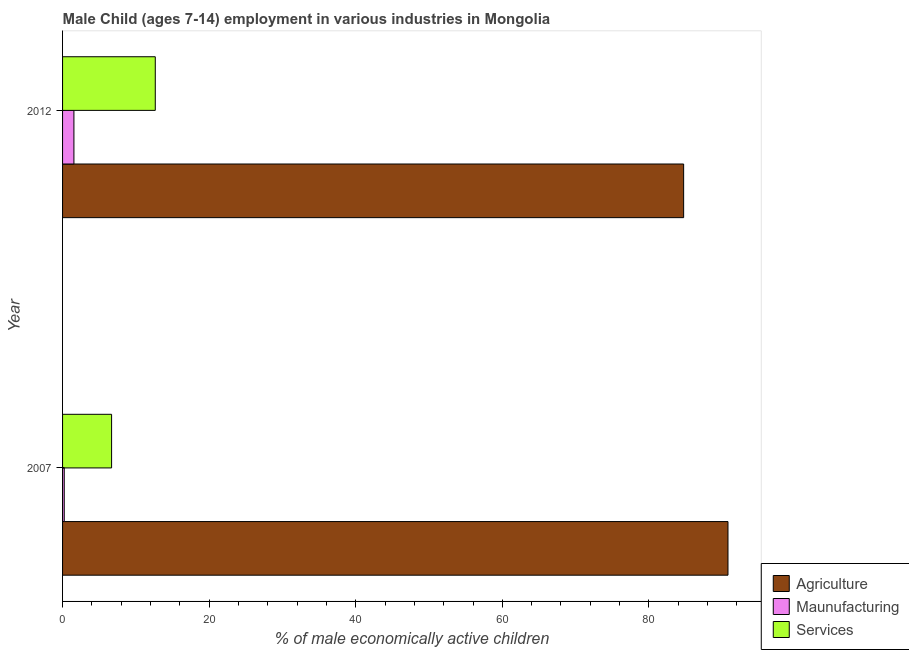How many different coloured bars are there?
Offer a very short reply. 3. How many groups of bars are there?
Your response must be concise. 2. Are the number of bars on each tick of the Y-axis equal?
Offer a very short reply. Yes. What is the percentage of economically active children in agriculture in 2007?
Provide a short and direct response. 90.79. Across all years, what is the maximum percentage of economically active children in manufacturing?
Make the answer very short. 1.55. Across all years, what is the minimum percentage of economically active children in services?
Your answer should be compact. 6.69. In which year was the percentage of economically active children in services minimum?
Provide a succinct answer. 2007. What is the total percentage of economically active children in manufacturing in the graph?
Make the answer very short. 1.78. What is the difference between the percentage of economically active children in services in 2007 and that in 2012?
Ensure brevity in your answer.  -5.96. What is the difference between the percentage of economically active children in services in 2007 and the percentage of economically active children in agriculture in 2012?
Your answer should be compact. -78.05. What is the average percentage of economically active children in manufacturing per year?
Your answer should be very brief. 0.89. In how many years, is the percentage of economically active children in manufacturing greater than 60 %?
Keep it short and to the point. 0. What is the ratio of the percentage of economically active children in services in 2007 to that in 2012?
Offer a terse response. 0.53. What does the 1st bar from the top in 2012 represents?
Your response must be concise. Services. What does the 2nd bar from the bottom in 2007 represents?
Ensure brevity in your answer.  Maunufacturing. Is it the case that in every year, the sum of the percentage of economically active children in agriculture and percentage of economically active children in manufacturing is greater than the percentage of economically active children in services?
Keep it short and to the point. Yes. Are all the bars in the graph horizontal?
Ensure brevity in your answer.  Yes. Are the values on the major ticks of X-axis written in scientific E-notation?
Provide a succinct answer. No. Does the graph contain any zero values?
Offer a terse response. No. How are the legend labels stacked?
Keep it short and to the point. Vertical. What is the title of the graph?
Provide a succinct answer. Male Child (ages 7-14) employment in various industries in Mongolia. Does "Maunufacturing" appear as one of the legend labels in the graph?
Provide a short and direct response. Yes. What is the label or title of the X-axis?
Provide a short and direct response. % of male economically active children. What is the label or title of the Y-axis?
Your answer should be compact. Year. What is the % of male economically active children of Agriculture in 2007?
Provide a short and direct response. 90.79. What is the % of male economically active children in Maunufacturing in 2007?
Provide a succinct answer. 0.23. What is the % of male economically active children of Services in 2007?
Ensure brevity in your answer.  6.69. What is the % of male economically active children in Agriculture in 2012?
Your answer should be very brief. 84.74. What is the % of male economically active children in Maunufacturing in 2012?
Offer a terse response. 1.55. What is the % of male economically active children of Services in 2012?
Provide a succinct answer. 12.65. Across all years, what is the maximum % of male economically active children of Agriculture?
Provide a succinct answer. 90.79. Across all years, what is the maximum % of male economically active children in Maunufacturing?
Offer a very short reply. 1.55. Across all years, what is the maximum % of male economically active children in Services?
Offer a very short reply. 12.65. Across all years, what is the minimum % of male economically active children of Agriculture?
Your answer should be very brief. 84.74. Across all years, what is the minimum % of male economically active children in Maunufacturing?
Your answer should be very brief. 0.23. Across all years, what is the minimum % of male economically active children of Services?
Provide a short and direct response. 6.69. What is the total % of male economically active children of Agriculture in the graph?
Your answer should be compact. 175.53. What is the total % of male economically active children in Maunufacturing in the graph?
Offer a terse response. 1.78. What is the total % of male economically active children in Services in the graph?
Ensure brevity in your answer.  19.34. What is the difference between the % of male economically active children of Agriculture in 2007 and that in 2012?
Your answer should be very brief. 6.05. What is the difference between the % of male economically active children of Maunufacturing in 2007 and that in 2012?
Make the answer very short. -1.32. What is the difference between the % of male economically active children in Services in 2007 and that in 2012?
Your answer should be compact. -5.96. What is the difference between the % of male economically active children of Agriculture in 2007 and the % of male economically active children of Maunufacturing in 2012?
Offer a very short reply. 89.24. What is the difference between the % of male economically active children of Agriculture in 2007 and the % of male economically active children of Services in 2012?
Make the answer very short. 78.14. What is the difference between the % of male economically active children of Maunufacturing in 2007 and the % of male economically active children of Services in 2012?
Provide a short and direct response. -12.42. What is the average % of male economically active children in Agriculture per year?
Offer a terse response. 87.77. What is the average % of male economically active children in Maunufacturing per year?
Offer a terse response. 0.89. What is the average % of male economically active children of Services per year?
Your answer should be very brief. 9.67. In the year 2007, what is the difference between the % of male economically active children in Agriculture and % of male economically active children in Maunufacturing?
Provide a succinct answer. 90.56. In the year 2007, what is the difference between the % of male economically active children in Agriculture and % of male economically active children in Services?
Offer a terse response. 84.1. In the year 2007, what is the difference between the % of male economically active children in Maunufacturing and % of male economically active children in Services?
Your response must be concise. -6.46. In the year 2012, what is the difference between the % of male economically active children in Agriculture and % of male economically active children in Maunufacturing?
Provide a short and direct response. 83.19. In the year 2012, what is the difference between the % of male economically active children of Agriculture and % of male economically active children of Services?
Ensure brevity in your answer.  72.09. In the year 2012, what is the difference between the % of male economically active children of Maunufacturing and % of male economically active children of Services?
Offer a very short reply. -11.1. What is the ratio of the % of male economically active children of Agriculture in 2007 to that in 2012?
Provide a short and direct response. 1.07. What is the ratio of the % of male economically active children of Maunufacturing in 2007 to that in 2012?
Give a very brief answer. 0.15. What is the ratio of the % of male economically active children in Services in 2007 to that in 2012?
Your response must be concise. 0.53. What is the difference between the highest and the second highest % of male economically active children in Agriculture?
Your answer should be compact. 6.05. What is the difference between the highest and the second highest % of male economically active children of Maunufacturing?
Give a very brief answer. 1.32. What is the difference between the highest and the second highest % of male economically active children in Services?
Ensure brevity in your answer.  5.96. What is the difference between the highest and the lowest % of male economically active children in Agriculture?
Offer a terse response. 6.05. What is the difference between the highest and the lowest % of male economically active children of Maunufacturing?
Offer a terse response. 1.32. What is the difference between the highest and the lowest % of male economically active children of Services?
Provide a succinct answer. 5.96. 